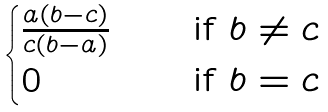<formula> <loc_0><loc_0><loc_500><loc_500>\begin{cases} \frac { a ( b - c ) } { c ( b - a ) } \quad & \text {if } b \ne c \\ 0 & \text {if } b = c \end{cases}</formula> 